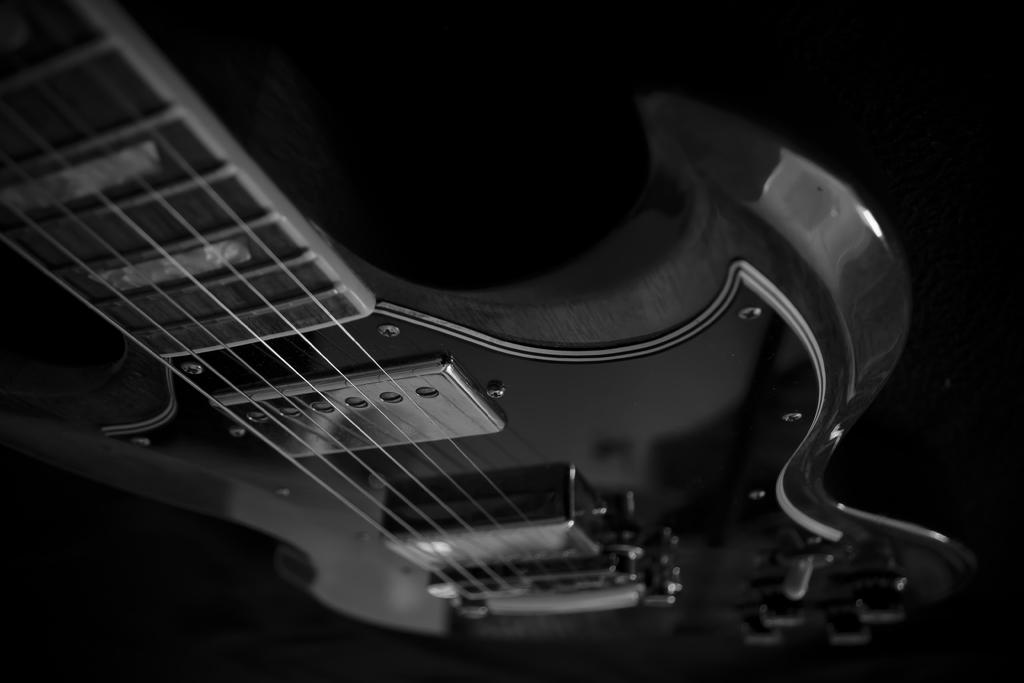What is the color scheme of the image? The image is black and white. What musical instrument is present in the image? There is a guitar in the image. What are the guitar's components that produce sound? The guitar has strings. What type of hardware is used to hold the guitar together? There are screws on the guitar. What additional features are present on the guitar? There are function keys on the guitar. How many goldfish are swimming in the bowl on the guitar? There are no goldfish or bowls present in the image; it features a black and white guitar with strings, screws, and function keys. 